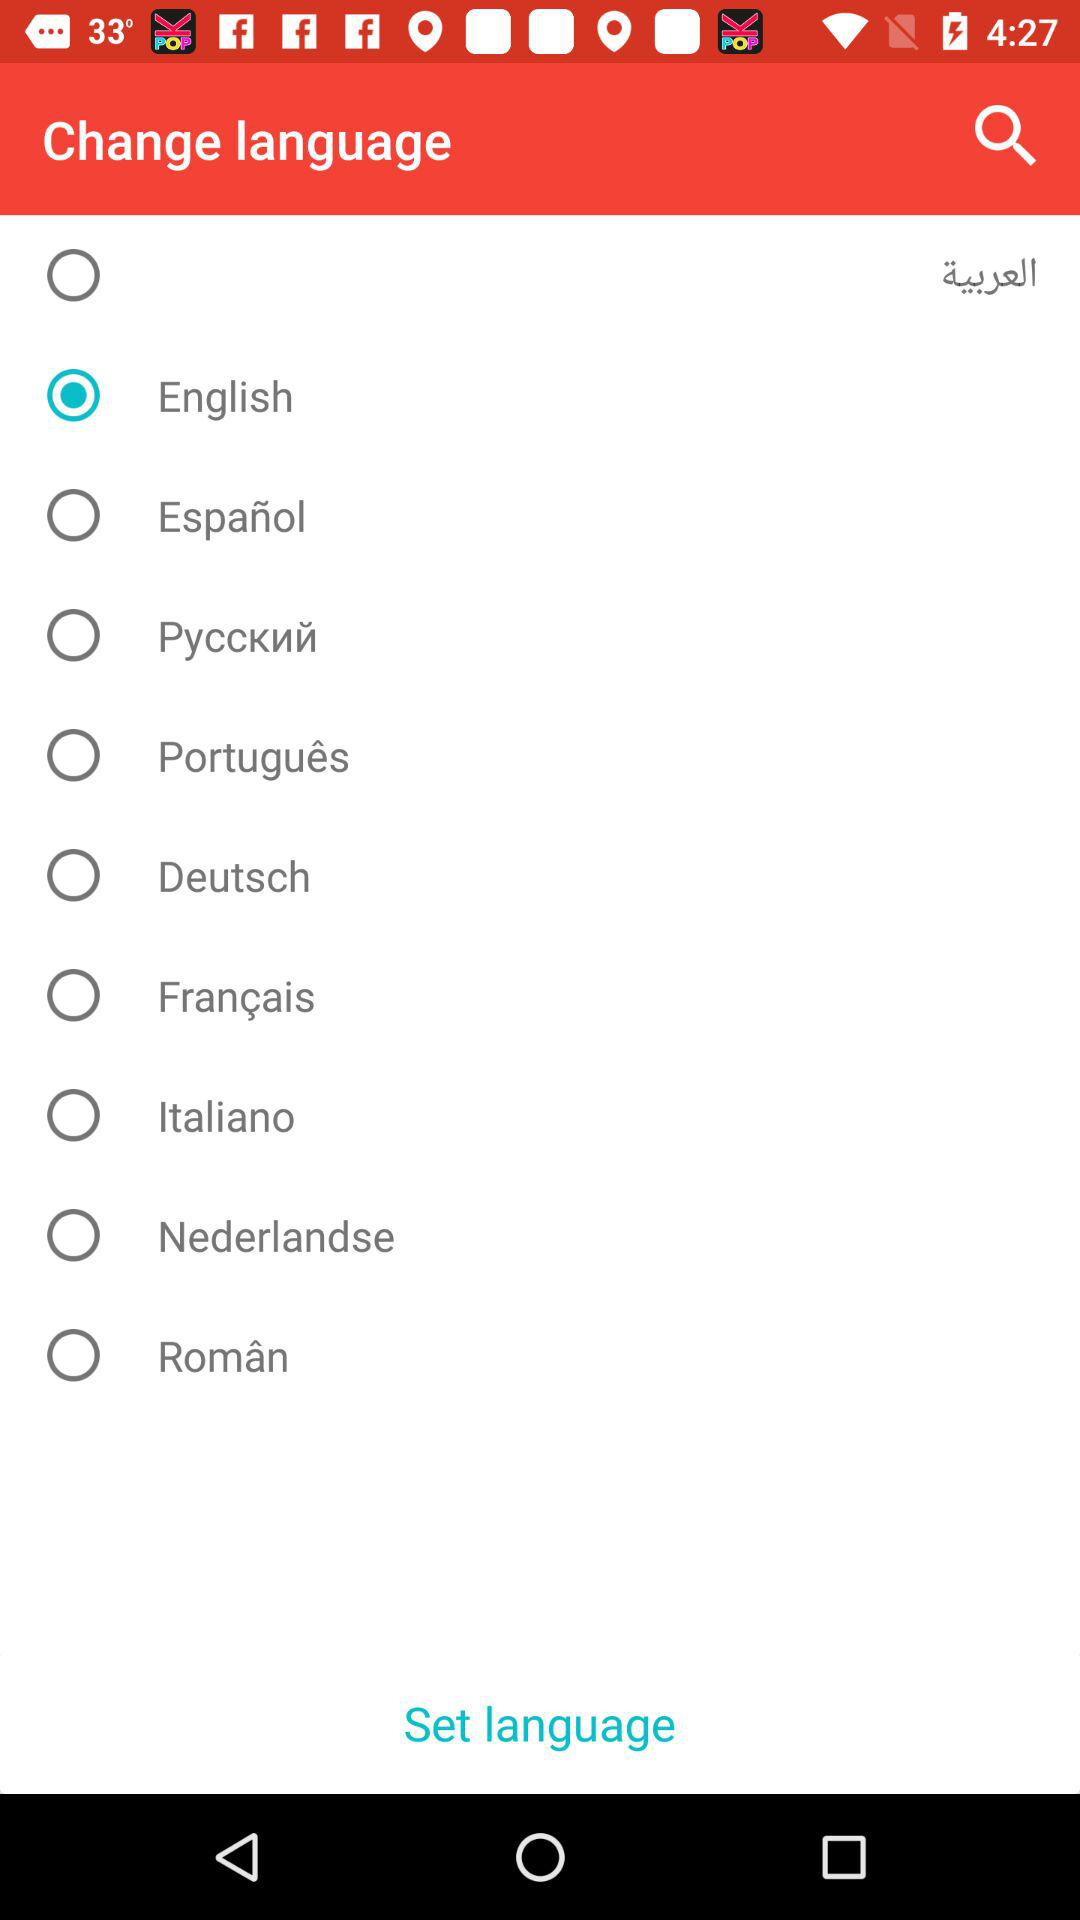How many languages are available in this app?
Answer the question using a single word or phrase. 10 